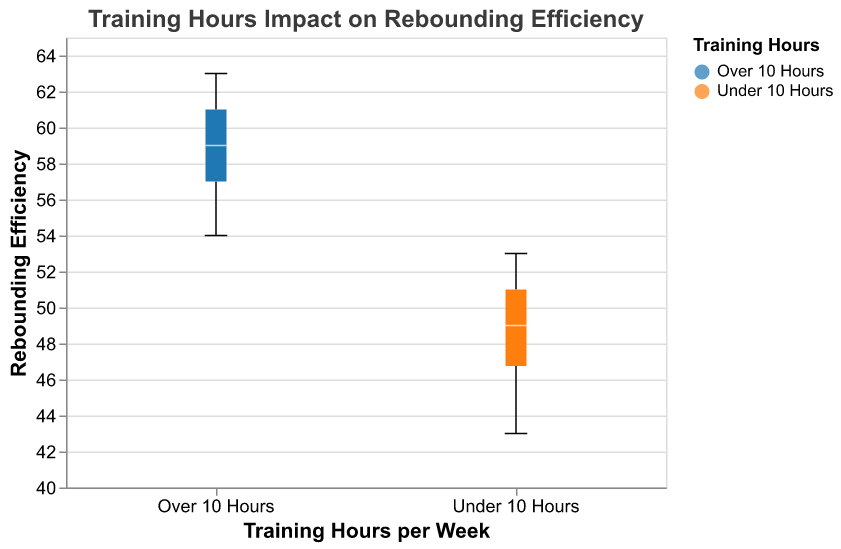What is the median rebounding efficiency for players training under 10 hours per week? The median is the middle value of the rebounding efficiency data points for players training under 10 hours per week. Look for the line inside the box plot for the "Under 10 Hours" group.
Answer: 49.5 What training group appears to have a higher overall median rebounding efficiency? Compare the position of the median lines inside the box plots for both "Under 10 Hours" and "Over 10 Hours" groups. The higher median line indicates a higher overall median rebounding efficiency.
Answer: Over 10 Hours What is the range of rebounding efficiencies for players training over 10 hours per week? The range is the difference between the maximum and minimum values in the "Over 10 Hours" group. Look for the top and bottom vertical lines of the "Over 10 Hours" group box plot.
Answer: 55 to 63 Which training group has a greater variability in rebounding efficiency? Variability can be assessed by the interquartile range (width of the box) and the range (length between whiskers). The group with the wider box and longer whiskers has greater variability.
Answer: Over 10 Hours What is the lower quartile (Q1) of rebounding efficiency for players training under 10 hours per week? Identify the lower boundary of the box for the "Under 10 Hours" group, which represents the 25th percentile (Q1) of the data.
Answer: 47 Does training over 10 hours per week guarantee a rebounding efficiency above 55? Verify if the minimum value (bottom whisker) in the "Over 10 Hours" group box plot is above 55.
Answer: No What is the interquartile range (IQR) for the "Under 10 Hours" training group? IQR is calculated as the difference between the third quartile (Q3) and the first quartile (Q1). Observe the edges of the box representing Q3 and Q1.
Answer: 4 (51 - 47) Compare the maximum rebounding efficiency for both training groups. Which group has the higher maximum value? Look at the top whisker (maximum value) of both box plots and compare their lengths.
Answer: Over 10 Hours Are there any outliers visible in either of the training groups? Outliers are typically represented as points outside the whiskers of the box plots. Inspect both plots for any individual points outside the typical range.
Answer: No Which training group has a higher median rebounding efficiency, and what does this imply about the impact of training hours on rebounding efficiency? Determine which group has the higher median by identifying the median lines inside the box plots, and infer the relationship between training hours and rebounding efficiency.
Answer: Over 10 Hours, suggests higher training hours may improve rebounding efficiency 